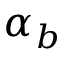Convert formula to latex. <formula><loc_0><loc_0><loc_500><loc_500>\alpha _ { b }</formula> 